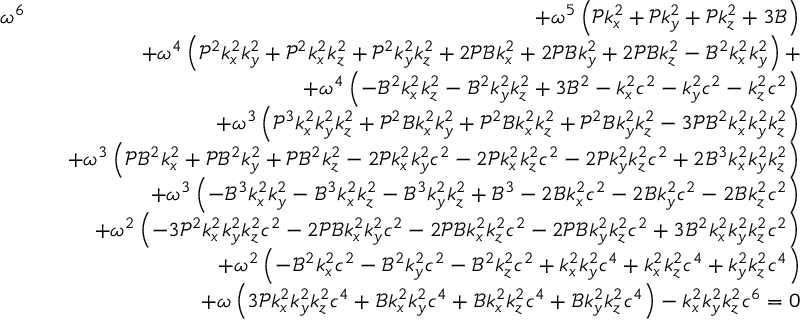Convert formula to latex. <formula><loc_0><loc_0><loc_500><loc_500>\begin{array} { r l r } { \omega ^ { 6 } } & { + \omega ^ { 5 } \left ( \mathcal { P } k _ { x } ^ { 2 } + \mathcal { P } k _ { y } ^ { 2 } + \mathcal { P } k _ { z } ^ { 2 } + 3 \mathcal { B } \right ) } \\ & { + \omega ^ { 4 } \left ( \mathcal { P } ^ { 2 } k _ { x } ^ { 2 } k _ { y } ^ { 2 } + \mathcal { P } ^ { 2 } k _ { x } ^ { 2 } k _ { z } ^ { 2 } + \mathcal { P } ^ { 2 } k _ { y } ^ { 2 } k _ { z } ^ { 2 } + 2 \mathcal { P } \mathcal { B } k _ { x } ^ { 2 } + 2 \mathcal { P } \mathcal { B } k _ { y } ^ { 2 } + 2 \mathcal { P } \mathcal { B } k _ { z } ^ { 2 } - \mathcal { B } ^ { 2 } k _ { x } ^ { 2 } k _ { y } ^ { 2 } \right ) + } \\ & { + \omega ^ { 4 } \left ( - \mathcal { B } ^ { 2 } k _ { x } ^ { 2 } k _ { z } ^ { 2 } - \mathcal { B } ^ { 2 } k _ { y } ^ { 2 } k _ { z } ^ { 2 } + 3 \mathcal { B } ^ { 2 } - k _ { x } ^ { 2 } c ^ { 2 } - k _ { y } ^ { 2 } c ^ { 2 } - k _ { z } ^ { 2 } c ^ { 2 } \right ) } \\ & { + \omega ^ { 3 } \left ( \mathcal { P } ^ { 3 } k _ { x } ^ { 2 } k _ { y } ^ { 2 } k _ { z } ^ { 2 } + \mathcal { P } ^ { 2 } \mathcal { B } k _ { x } ^ { 2 } k _ { y } ^ { 2 } + \mathcal { P } ^ { 2 } \mathcal { B } k _ { x } ^ { 2 } k _ { z } ^ { 2 } + \mathcal { P } ^ { 2 } \mathcal { B } k _ { y } ^ { 2 } k _ { z } ^ { 2 } - 3 \mathcal { P } \mathcal { B } ^ { 2 } k _ { x } ^ { 2 } k _ { y } ^ { 2 } k _ { z } ^ { 2 } \right ) } \\ & { + \omega ^ { 3 } \left ( \mathcal { P } \mathcal { B } ^ { 2 } k _ { x } ^ { 2 } + \mathcal { P } \mathcal { B } ^ { 2 } k _ { y } ^ { 2 } + \mathcal { P } \mathcal { B } ^ { 2 } k _ { z } ^ { 2 } - 2 \mathcal { P } k _ { x } ^ { 2 } k _ { y } ^ { 2 } c ^ { 2 } - 2 \mathcal { P } k _ { x } ^ { 2 } k _ { z } ^ { 2 } c ^ { 2 } - 2 \mathcal { P } k _ { y } ^ { 2 } k _ { z } ^ { 2 } c ^ { 2 } + 2 \mathcal { B } ^ { 3 } k _ { x } ^ { 2 } k _ { y } ^ { 2 } k _ { z } ^ { 2 } \right ) } \\ & { + \omega ^ { 3 } \left ( - \mathcal { B } ^ { 3 } k _ { x } ^ { 2 } k _ { y } ^ { 2 } - \mathcal { B } ^ { 3 } k _ { x } ^ { 2 } k _ { z } ^ { 2 } - \mathcal { B } ^ { 3 } k _ { y } ^ { 2 } k _ { z } ^ { 2 } + \mathcal { B } ^ { 3 } - 2 \mathcal { B } k _ { x } ^ { 2 } c ^ { 2 } - 2 \mathcal { B } k _ { y } ^ { 2 } c ^ { 2 } - 2 \mathcal { B } k _ { z } ^ { 2 } c ^ { 2 } \right ) } \\ & { + \omega ^ { 2 } \left ( - 3 \mathcal { P } ^ { 2 } k _ { x } ^ { 2 } k _ { y } ^ { 2 } k _ { z } ^ { 2 } c ^ { 2 } - 2 \mathcal { P } \mathcal { B } k _ { x } ^ { 2 } k _ { y } ^ { 2 } c ^ { 2 } - 2 \mathcal { P } \mathcal { B } k _ { x } ^ { 2 } k _ { z } ^ { 2 } c ^ { 2 } - 2 \mathcal { P } \mathcal { B } k _ { y } ^ { 2 } k _ { z } ^ { 2 } c ^ { 2 } + 3 \mathcal { B } ^ { 2 } k _ { x } ^ { 2 } k _ { y } ^ { 2 } k _ { z } ^ { 2 } c ^ { 2 } \right ) } \\ & { + \omega ^ { 2 } \left ( - \mathcal { B } ^ { 2 } k _ { x } ^ { 2 } c ^ { 2 } - \mathcal { B } ^ { 2 } k _ { y } ^ { 2 } c ^ { 2 } - \mathcal { B } ^ { 2 } k _ { z } ^ { 2 } c ^ { 2 } + k _ { x } ^ { 2 } k _ { y } ^ { 2 } c ^ { 4 } + k _ { x } ^ { 2 } k _ { z } ^ { 2 } c ^ { 4 } + k _ { y } ^ { 2 } k _ { z } ^ { 2 } c ^ { 4 } \right ) } \\ & { + \omega \left ( 3 \mathcal { P } k _ { x } ^ { 2 } k _ { y } ^ { 2 } k _ { z } ^ { 2 } c ^ { 4 } + \mathcal { B } k _ { x } ^ { 2 } k _ { y } ^ { 2 } c ^ { 4 } + \mathcal { B } k _ { x } ^ { 2 } k _ { z } ^ { 2 } c ^ { 4 } + \mathcal { B } k _ { y } ^ { 2 } k _ { z } ^ { 2 } c ^ { 4 } \right ) - k _ { x } ^ { 2 } k _ { y } ^ { 2 } k _ { z } ^ { 2 } c ^ { 6 } = 0 } \end{array}</formula> 